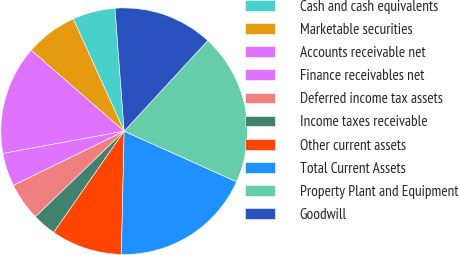Convert chart. <chart><loc_0><loc_0><loc_500><loc_500><pie_chart><fcel>Cash and cash equivalents<fcel>Marketable securities<fcel>Accounts receivable net<fcel>Finance receivables net<fcel>Deferred income tax assets<fcel>Income taxes receivable<fcel>Other current assets<fcel>Total Current Assets<fcel>Property Plant and Equipment<fcel>Goodwill<nl><fcel>5.59%<fcel>6.83%<fcel>14.29%<fcel>4.35%<fcel>4.97%<fcel>3.11%<fcel>9.32%<fcel>18.63%<fcel>19.88%<fcel>13.04%<nl></chart> 